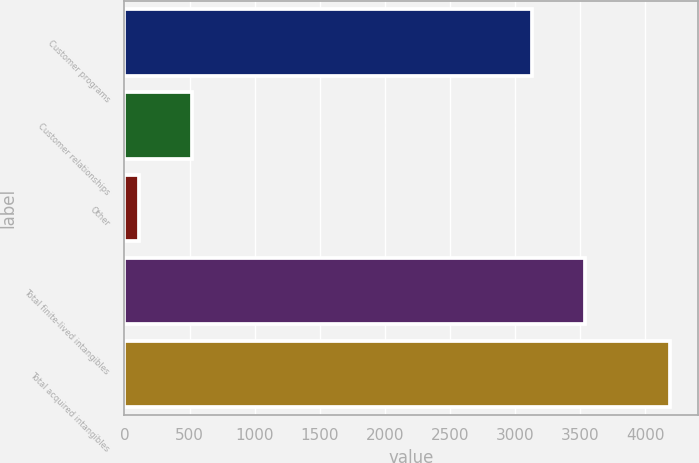<chart> <loc_0><loc_0><loc_500><loc_500><bar_chart><fcel>Customer programs<fcel>Customer relationships<fcel>Other<fcel>Total finite-lived intangibles<fcel>Total acquired intangibles<nl><fcel>3127<fcel>519<fcel>111<fcel>3535<fcel>4191<nl></chart> 